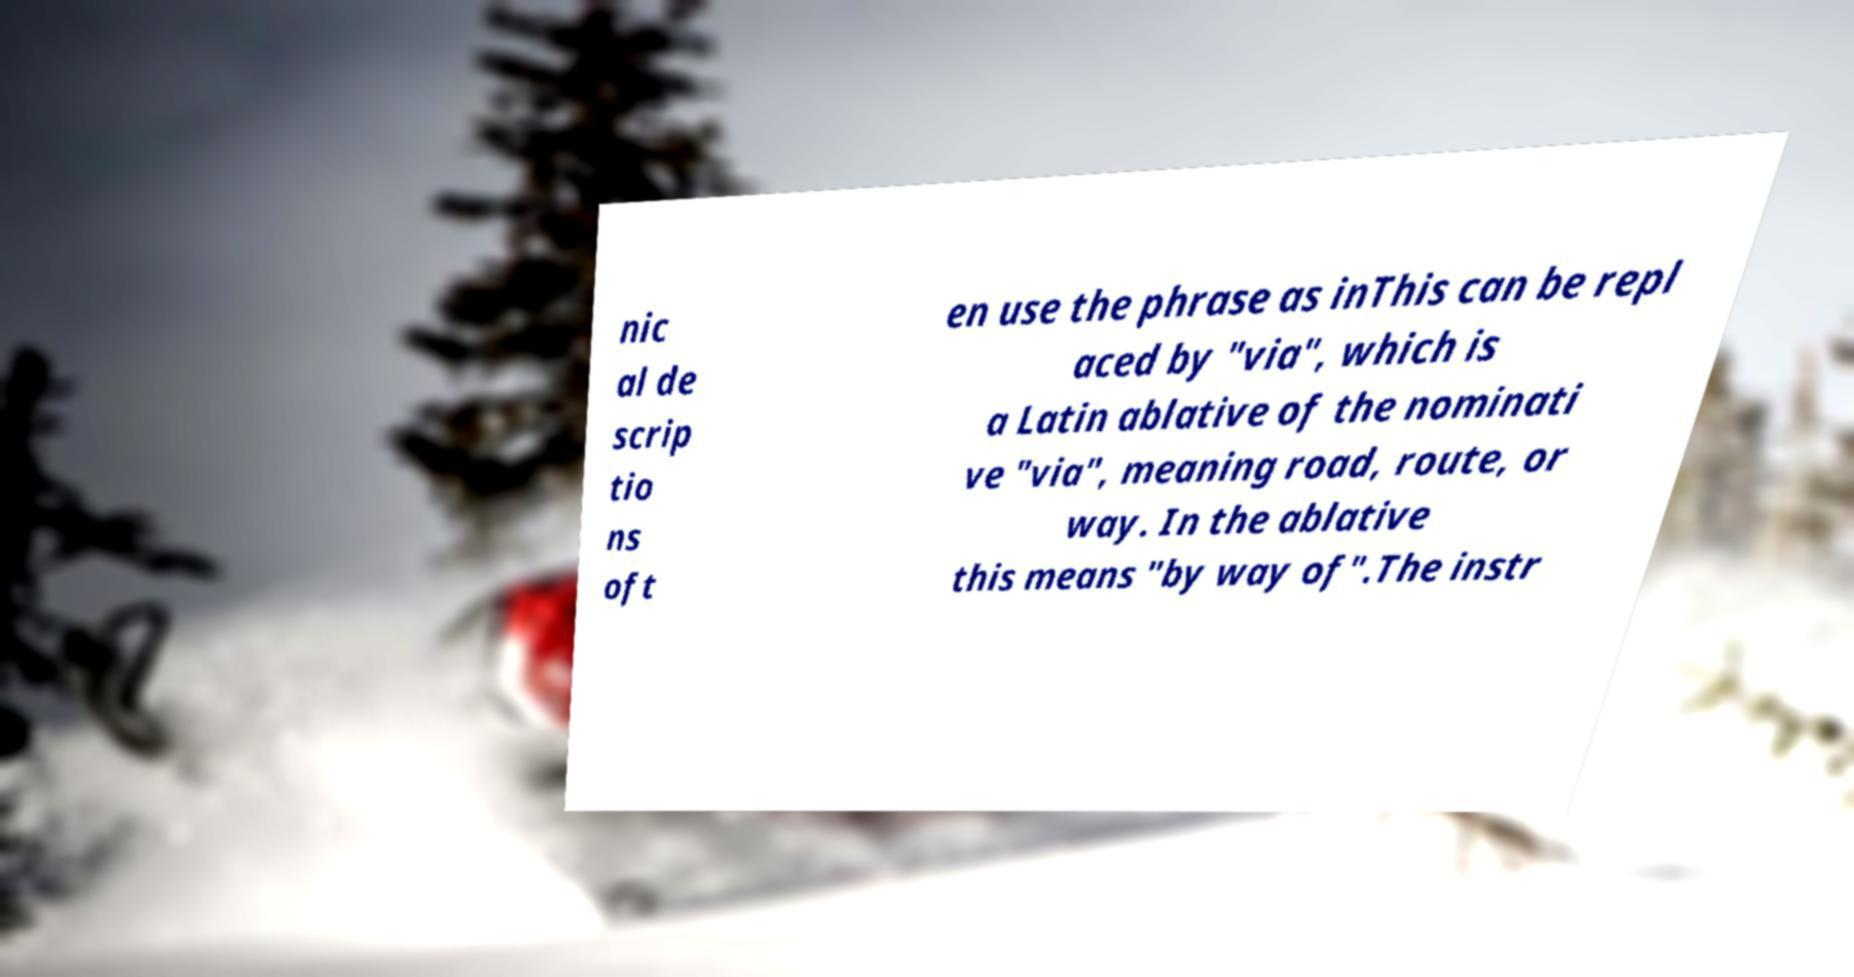For documentation purposes, I need the text within this image transcribed. Could you provide that? nic al de scrip tio ns oft en use the phrase as inThis can be repl aced by "via", which is a Latin ablative of the nominati ve "via", meaning road, route, or way. In the ablative this means "by way of".The instr 